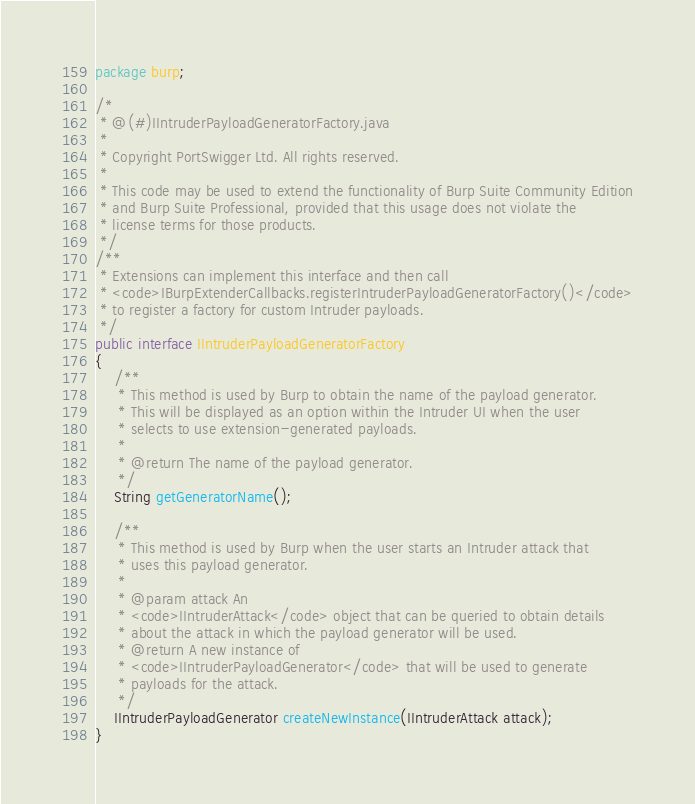Convert code to text. <code><loc_0><loc_0><loc_500><loc_500><_Java_>package burp;

/*
 * @(#)IIntruderPayloadGeneratorFactory.java
 *
 * Copyright PortSwigger Ltd. All rights reserved.
 *
 * This code may be used to extend the functionality of Burp Suite Community Edition
 * and Burp Suite Professional, provided that this usage does not violate the
 * license terms for those products.
 */
/**
 * Extensions can implement this interface and then call
 * <code>IBurpExtenderCallbacks.registerIntruderPayloadGeneratorFactory()</code>
 * to register a factory for custom Intruder payloads.
 */
public interface IIntruderPayloadGeneratorFactory
{
    /**
     * This method is used by Burp to obtain the name of the payload generator.
     * This will be displayed as an option within the Intruder UI when the user
     * selects to use extension-generated payloads.
     *
     * @return The name of the payload generator.
     */
    String getGeneratorName();

    /**
     * This method is used by Burp when the user starts an Intruder attack that
     * uses this payload generator.
     *
     * @param attack An
     * <code>IIntruderAttack</code> object that can be queried to obtain details
     * about the attack in which the payload generator will be used.
     * @return A new instance of
     * <code>IIntruderPayloadGenerator</code> that will be used to generate
     * payloads for the attack.
     */
    IIntruderPayloadGenerator createNewInstance(IIntruderAttack attack);
}
</code> 